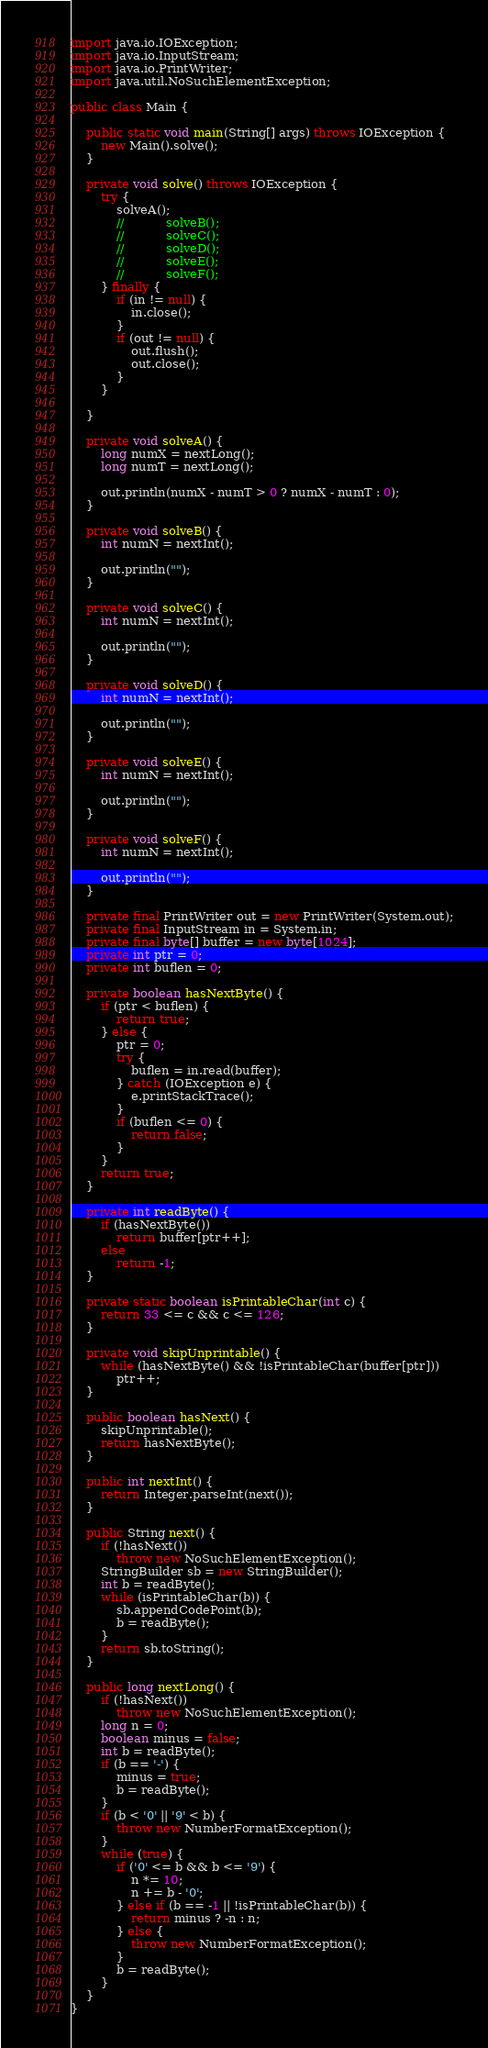<code> <loc_0><loc_0><loc_500><loc_500><_Java_>
import java.io.IOException;
import java.io.InputStream;
import java.io.PrintWriter;
import java.util.NoSuchElementException;

public class Main {

	public static void main(String[] args) throws IOException {
		new Main().solve();
	}

	private void solve() throws IOException {
		try {
			solveA();
			//			 solveB();
			//			 solveC();
			//			 solveD();
			//			 solveE();
			//			 solveF();
		} finally {
			if (in != null) {
				in.close();
			}
			if (out != null) {
				out.flush();
				out.close();
			}
		}

	}

	private void solveA() {
		long numX = nextLong();
		long numT = nextLong();

		out.println(numX - numT > 0 ? numX - numT : 0);
	}

	private void solveB() {
		int numN = nextInt();

		out.println("");
	}

	private void solveC() {
		int numN = nextInt();

		out.println("");
	}

	private void solveD() {
		int numN = nextInt();

		out.println("");
	}

	private void solveE() {
		int numN = nextInt();

		out.println("");
	}

	private void solveF() {
		int numN = nextInt();

		out.println("");
	}

	private final PrintWriter out = new PrintWriter(System.out);
	private final InputStream in = System.in;
	private final byte[] buffer = new byte[1024];
	private int ptr = 0;
	private int buflen = 0;

	private boolean hasNextByte() {
		if (ptr < buflen) {
			return true;
		} else {
			ptr = 0;
			try {
				buflen = in.read(buffer);
			} catch (IOException e) {
				e.printStackTrace();
			}
			if (buflen <= 0) {
				return false;
			}
		}
		return true;
	}

	private int readByte() {
		if (hasNextByte())
			return buffer[ptr++];
		else
			return -1;
	}

	private static boolean isPrintableChar(int c) {
		return 33 <= c && c <= 126;
	}

	private void skipUnprintable() {
		while (hasNextByte() && !isPrintableChar(buffer[ptr]))
			ptr++;
	}

	public boolean hasNext() {
		skipUnprintable();
		return hasNextByte();
	}

	public int nextInt() {
		return Integer.parseInt(next());
	}

	public String next() {
		if (!hasNext())
			throw new NoSuchElementException();
		StringBuilder sb = new StringBuilder();
		int b = readByte();
		while (isPrintableChar(b)) {
			sb.appendCodePoint(b);
			b = readByte();
		}
		return sb.toString();
	}

	public long nextLong() {
		if (!hasNext())
			throw new NoSuchElementException();
		long n = 0;
		boolean minus = false;
		int b = readByte();
		if (b == '-') {
			minus = true;
			b = readByte();
		}
		if (b < '0' || '9' < b) {
			throw new NumberFormatException();
		}
		while (true) {
			if ('0' <= b && b <= '9') {
				n *= 10;
				n += b - '0';
			} else if (b == -1 || !isPrintableChar(b)) {
				return minus ? -n : n;
			} else {
				throw new NumberFormatException();
			}
			b = readByte();
		}
	}
}</code> 